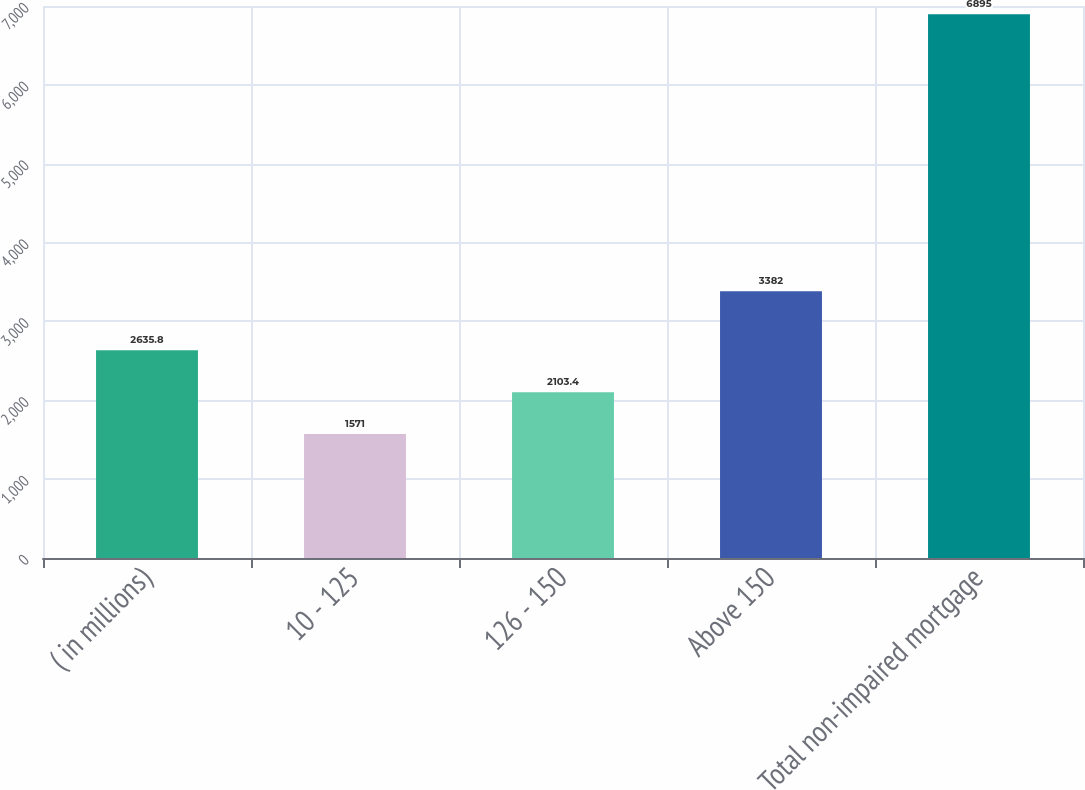Convert chart to OTSL. <chart><loc_0><loc_0><loc_500><loc_500><bar_chart><fcel>( in millions)<fcel>10 - 125<fcel>126 - 150<fcel>Above 150<fcel>Total non-impaired mortgage<nl><fcel>2635.8<fcel>1571<fcel>2103.4<fcel>3382<fcel>6895<nl></chart> 